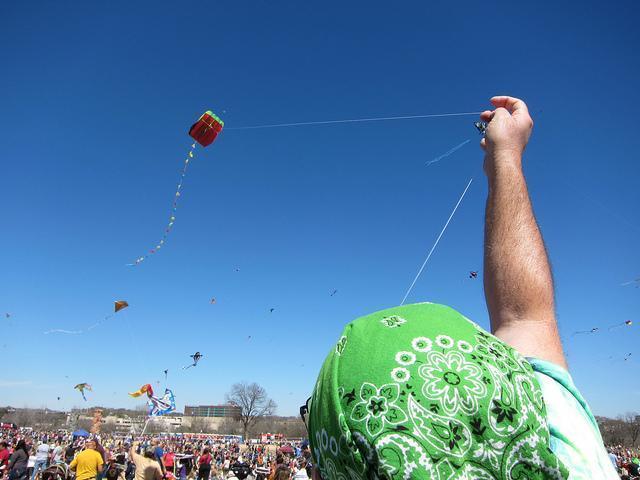How many people are visible?
Give a very brief answer. 2. 